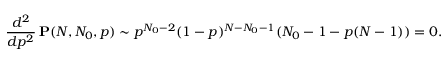Convert formula to latex. <formula><loc_0><loc_0><loc_500><loc_500>\frac { d ^ { 2 } } { d p ^ { 2 } } \, P ( N , N _ { 0 } , p ) \sim p ^ { N _ { 0 } - 2 } ( 1 - p ) ^ { N - N _ { 0 } - 1 } ( N _ { 0 } - 1 - p ( N - 1 ) ) = 0 .</formula> 